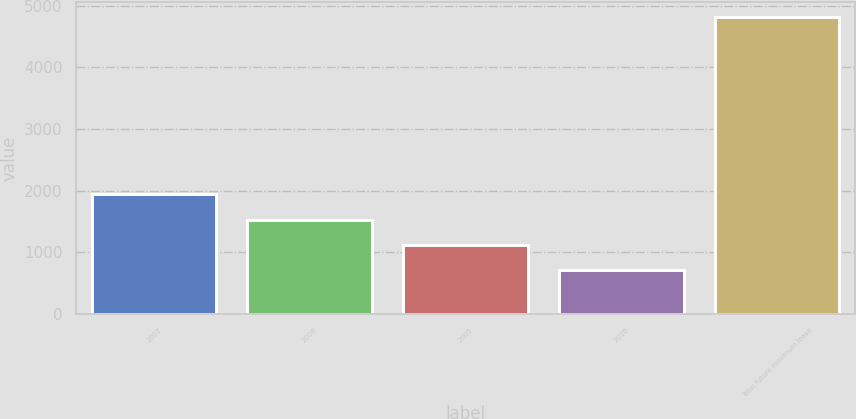Convert chart. <chart><loc_0><loc_0><loc_500><loc_500><bar_chart><fcel>2007<fcel>2008<fcel>2009<fcel>2010<fcel>Total future minimum lease<nl><fcel>1942.7<fcel>1531.8<fcel>1120.9<fcel>710<fcel>4819<nl></chart> 